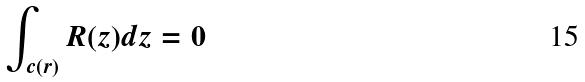<formula> <loc_0><loc_0><loc_500><loc_500>\int _ { c ( r ) } R ( z ) d z = 0</formula> 